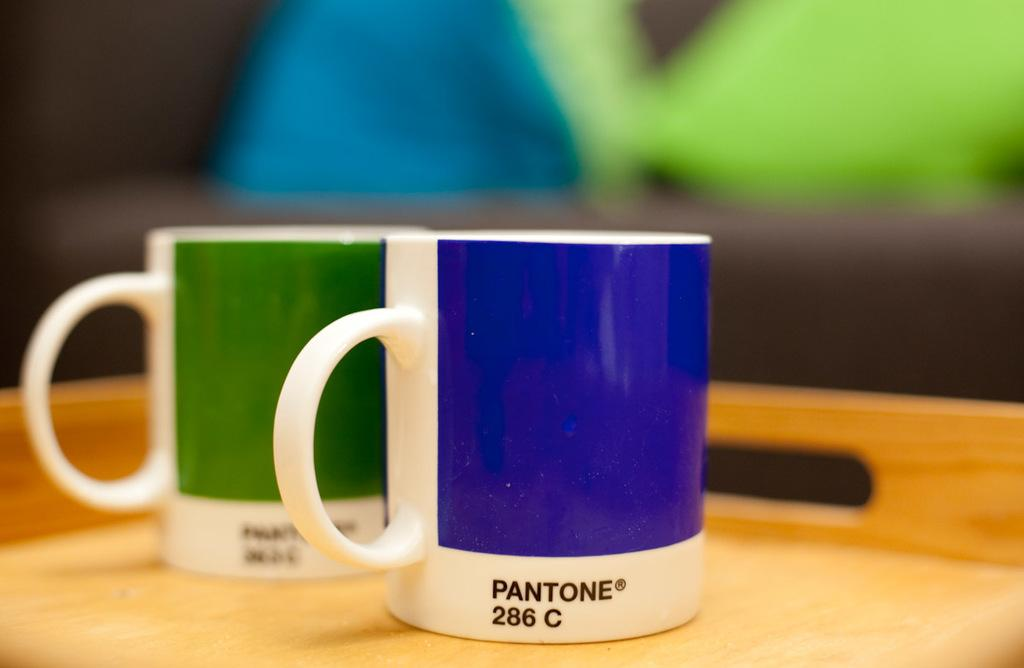<image>
Write a terse but informative summary of the picture. a cup that has Pantone written on it 